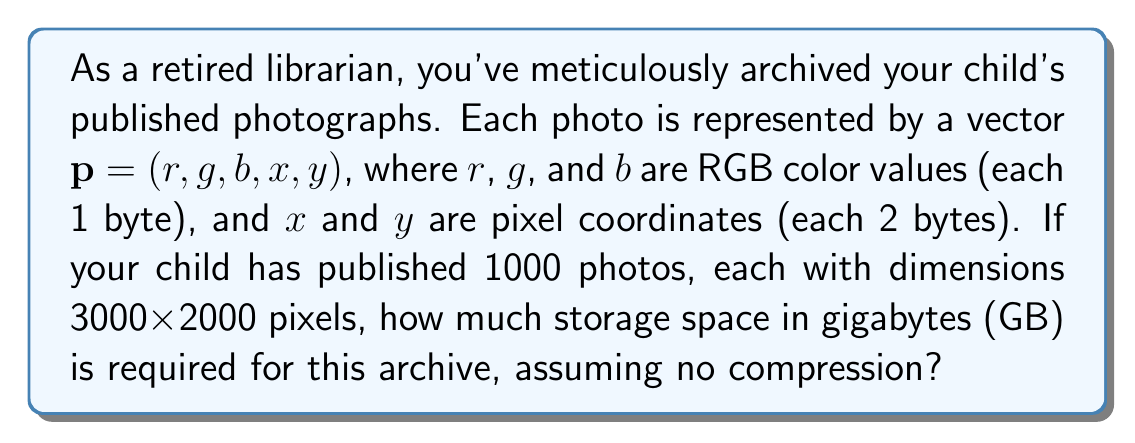Can you answer this question? Let's approach this step-by-step:

1) First, we need to calculate the number of pixels in each photo:
   $3000 \times 2000 = 6,000,000$ pixels per photo

2) Now, let's consider the vector $\mathbf{p} = (r, g, b, x, y)$ for each pixel:
   - $r$, $g$, $b$ each require 1 byte = 3 bytes total
   - $x$, $y$ each require 2 bytes = 4 bytes total
   - Total bytes per pixel vector: $3 + 4 = 7$ bytes

3) Calculate total bytes per photo:
   $6,000,000 \text{ pixels} \times 7 \text{ bytes/pixel} = 42,000,000 \text{ bytes}$

4) Calculate total bytes for all 1000 photos:
   $42,000,000 \text{ bytes} \times 1000 = 42,000,000,000 \text{ bytes}$

5) Convert bytes to gigabytes:
   $42,000,000,000 \text{ bytes} \times \frac{1 \text{ GB}}{1,000,000,000 \text{ bytes}} = 42 \text{ GB}$

Therefore, the total storage space required is 42 GB.
Answer: 42 GB 